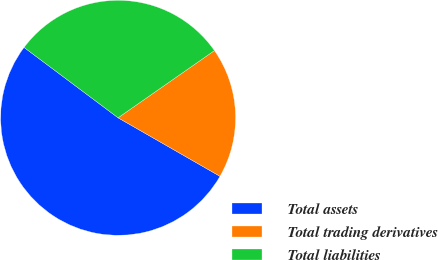<chart> <loc_0><loc_0><loc_500><loc_500><pie_chart><fcel>Total assets<fcel>Total trading derivatives<fcel>Total liabilities<nl><fcel>51.93%<fcel>17.99%<fcel>30.08%<nl></chart> 